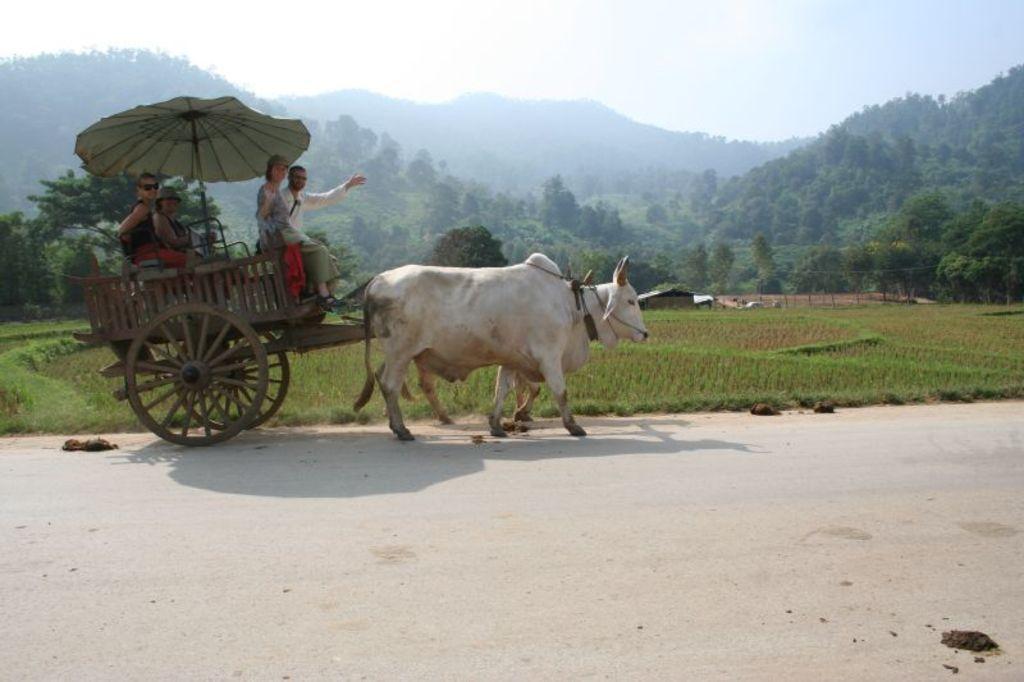Describe this image in one or two sentences. This picture shows a bullock cart and we see people seated on the cart and a umbrella. The color of the Bulls is white and we see trees and a house and we see field and a blue cloudy sky. 